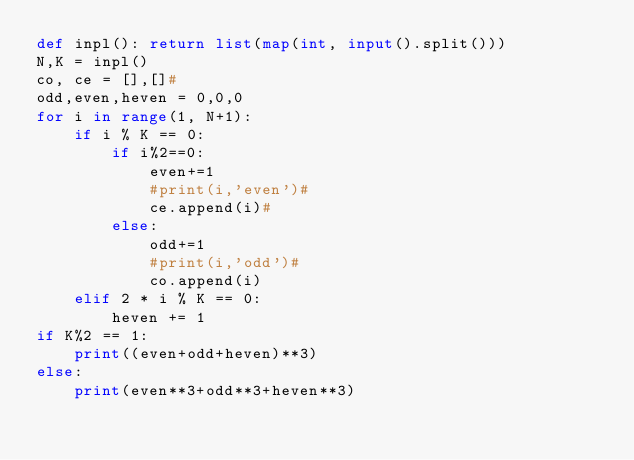Convert code to text. <code><loc_0><loc_0><loc_500><loc_500><_Python_>def inpl(): return list(map(int, input().split()))
N,K = inpl()
co, ce = [],[]#
odd,even,heven = 0,0,0
for i in range(1, N+1):
    if i % K == 0:
        if i%2==0:
            even+=1
            #print(i,'even')#
            ce.append(i)#
        else:
            odd+=1
            #print(i,'odd')#
            co.append(i)
    elif 2 * i % K == 0:
        heven += 1
if K%2 == 1:
    print((even+odd+heven)**3)
else:
    print(even**3+odd**3+heven**3)</code> 